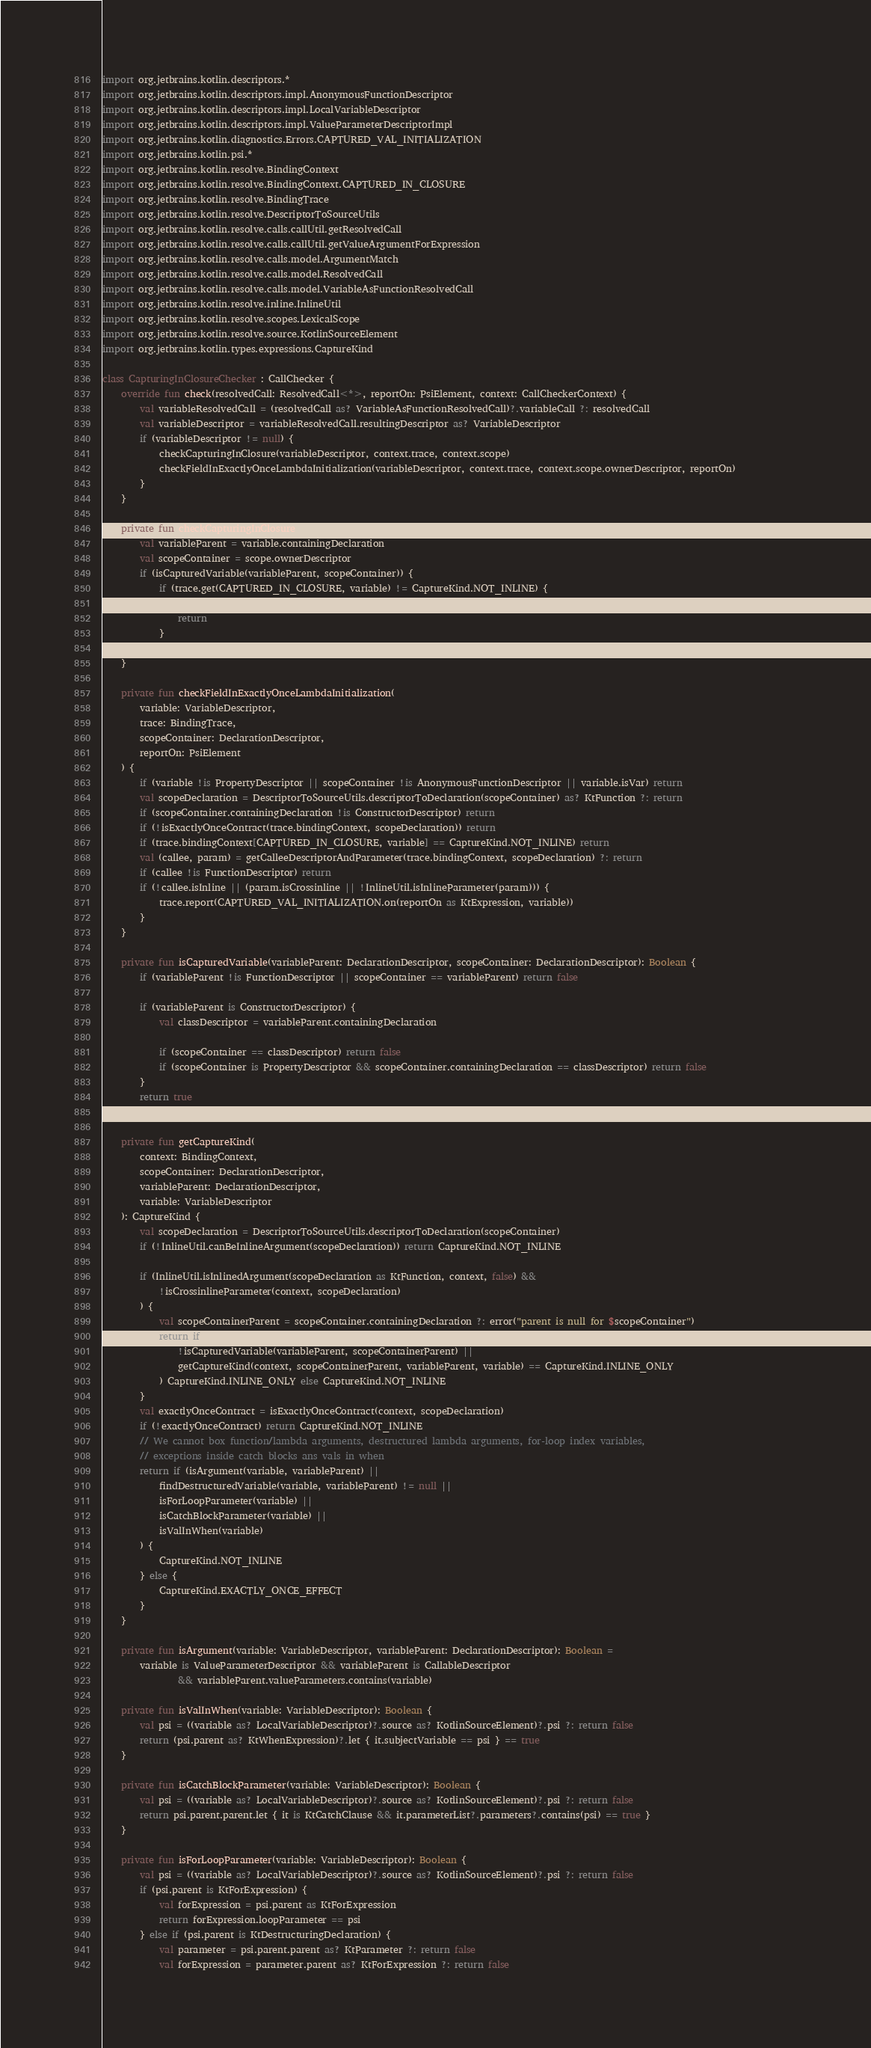<code> <loc_0><loc_0><loc_500><loc_500><_Kotlin_>import org.jetbrains.kotlin.descriptors.*
import org.jetbrains.kotlin.descriptors.impl.AnonymousFunctionDescriptor
import org.jetbrains.kotlin.descriptors.impl.LocalVariableDescriptor
import org.jetbrains.kotlin.descriptors.impl.ValueParameterDescriptorImpl
import org.jetbrains.kotlin.diagnostics.Errors.CAPTURED_VAL_INITIALIZATION
import org.jetbrains.kotlin.psi.*
import org.jetbrains.kotlin.resolve.BindingContext
import org.jetbrains.kotlin.resolve.BindingContext.CAPTURED_IN_CLOSURE
import org.jetbrains.kotlin.resolve.BindingTrace
import org.jetbrains.kotlin.resolve.DescriptorToSourceUtils
import org.jetbrains.kotlin.resolve.calls.callUtil.getResolvedCall
import org.jetbrains.kotlin.resolve.calls.callUtil.getValueArgumentForExpression
import org.jetbrains.kotlin.resolve.calls.model.ArgumentMatch
import org.jetbrains.kotlin.resolve.calls.model.ResolvedCall
import org.jetbrains.kotlin.resolve.calls.model.VariableAsFunctionResolvedCall
import org.jetbrains.kotlin.resolve.inline.InlineUtil
import org.jetbrains.kotlin.resolve.scopes.LexicalScope
import org.jetbrains.kotlin.resolve.source.KotlinSourceElement
import org.jetbrains.kotlin.types.expressions.CaptureKind

class CapturingInClosureChecker : CallChecker {
    override fun check(resolvedCall: ResolvedCall<*>, reportOn: PsiElement, context: CallCheckerContext) {
        val variableResolvedCall = (resolvedCall as? VariableAsFunctionResolvedCall)?.variableCall ?: resolvedCall
        val variableDescriptor = variableResolvedCall.resultingDescriptor as? VariableDescriptor
        if (variableDescriptor != null) {
            checkCapturingInClosure(variableDescriptor, context.trace, context.scope)
            checkFieldInExactlyOnceLambdaInitialization(variableDescriptor, context.trace, context.scope.ownerDescriptor, reportOn)
        }
    }

    private fun checkCapturingInClosure(variable: VariableDescriptor, trace: BindingTrace, scope: LexicalScope) {
        val variableParent = variable.containingDeclaration
        val scopeContainer = scope.ownerDescriptor
        if (isCapturedVariable(variableParent, scopeContainer)) {
            if (trace.get(CAPTURED_IN_CLOSURE, variable) != CaptureKind.NOT_INLINE) {
                trace.record(CAPTURED_IN_CLOSURE, variable, getCaptureKind(trace.bindingContext, scopeContainer, variableParent, variable))
                return
            }
        }
    }

    private fun checkFieldInExactlyOnceLambdaInitialization(
        variable: VariableDescriptor,
        trace: BindingTrace,
        scopeContainer: DeclarationDescriptor,
        reportOn: PsiElement
    ) {
        if (variable !is PropertyDescriptor || scopeContainer !is AnonymousFunctionDescriptor || variable.isVar) return
        val scopeDeclaration = DescriptorToSourceUtils.descriptorToDeclaration(scopeContainer) as? KtFunction ?: return
        if (scopeContainer.containingDeclaration !is ConstructorDescriptor) return
        if (!isExactlyOnceContract(trace.bindingContext, scopeDeclaration)) return
        if (trace.bindingContext[CAPTURED_IN_CLOSURE, variable] == CaptureKind.NOT_INLINE) return
        val (callee, param) = getCalleeDescriptorAndParameter(trace.bindingContext, scopeDeclaration) ?: return
        if (callee !is FunctionDescriptor) return
        if (!callee.isInline || (param.isCrossinline || !InlineUtil.isInlineParameter(param))) {
            trace.report(CAPTURED_VAL_INITIALIZATION.on(reportOn as KtExpression, variable))
        }
    }

    private fun isCapturedVariable(variableParent: DeclarationDescriptor, scopeContainer: DeclarationDescriptor): Boolean {
        if (variableParent !is FunctionDescriptor || scopeContainer == variableParent) return false

        if (variableParent is ConstructorDescriptor) {
            val classDescriptor = variableParent.containingDeclaration

            if (scopeContainer == classDescriptor) return false
            if (scopeContainer is PropertyDescriptor && scopeContainer.containingDeclaration == classDescriptor) return false
        }
        return true
    }

    private fun getCaptureKind(
        context: BindingContext,
        scopeContainer: DeclarationDescriptor,
        variableParent: DeclarationDescriptor,
        variable: VariableDescriptor
    ): CaptureKind {
        val scopeDeclaration = DescriptorToSourceUtils.descriptorToDeclaration(scopeContainer)
        if (!InlineUtil.canBeInlineArgument(scopeDeclaration)) return CaptureKind.NOT_INLINE

        if (InlineUtil.isInlinedArgument(scopeDeclaration as KtFunction, context, false) &&
            !isCrossinlineParameter(context, scopeDeclaration)
        ) {
            val scopeContainerParent = scopeContainer.containingDeclaration ?: error("parent is null for $scopeContainer")
            return if (
                !isCapturedVariable(variableParent, scopeContainerParent) ||
                getCaptureKind(context, scopeContainerParent, variableParent, variable) == CaptureKind.INLINE_ONLY
            ) CaptureKind.INLINE_ONLY else CaptureKind.NOT_INLINE
        }
        val exactlyOnceContract = isExactlyOnceContract(context, scopeDeclaration)
        if (!exactlyOnceContract) return CaptureKind.NOT_INLINE
        // We cannot box function/lambda arguments, destructured lambda arguments, for-loop index variables,
        // exceptions inside catch blocks ans vals in when
        return if (isArgument(variable, variableParent) ||
            findDestructuredVariable(variable, variableParent) != null ||
            isForLoopParameter(variable) ||
            isCatchBlockParameter(variable) ||
            isValInWhen(variable)
        ) {
            CaptureKind.NOT_INLINE
        } else {
            CaptureKind.EXACTLY_ONCE_EFFECT
        }
    }

    private fun isArgument(variable: VariableDescriptor, variableParent: DeclarationDescriptor): Boolean =
        variable is ValueParameterDescriptor && variableParent is CallableDescriptor
                && variableParent.valueParameters.contains(variable)

    private fun isValInWhen(variable: VariableDescriptor): Boolean {
        val psi = ((variable as? LocalVariableDescriptor)?.source as? KotlinSourceElement)?.psi ?: return false
        return (psi.parent as? KtWhenExpression)?.let { it.subjectVariable == psi } == true
    }

    private fun isCatchBlockParameter(variable: VariableDescriptor): Boolean {
        val psi = ((variable as? LocalVariableDescriptor)?.source as? KotlinSourceElement)?.psi ?: return false
        return psi.parent.parent.let { it is KtCatchClause && it.parameterList?.parameters?.contains(psi) == true }
    }

    private fun isForLoopParameter(variable: VariableDescriptor): Boolean {
        val psi = ((variable as? LocalVariableDescriptor)?.source as? KotlinSourceElement)?.psi ?: return false
        if (psi.parent is KtForExpression) {
            val forExpression = psi.parent as KtForExpression
            return forExpression.loopParameter == psi
        } else if (psi.parent is KtDestructuringDeclaration) {
            val parameter = psi.parent.parent as? KtParameter ?: return false
            val forExpression = parameter.parent as? KtForExpression ?: return false</code> 